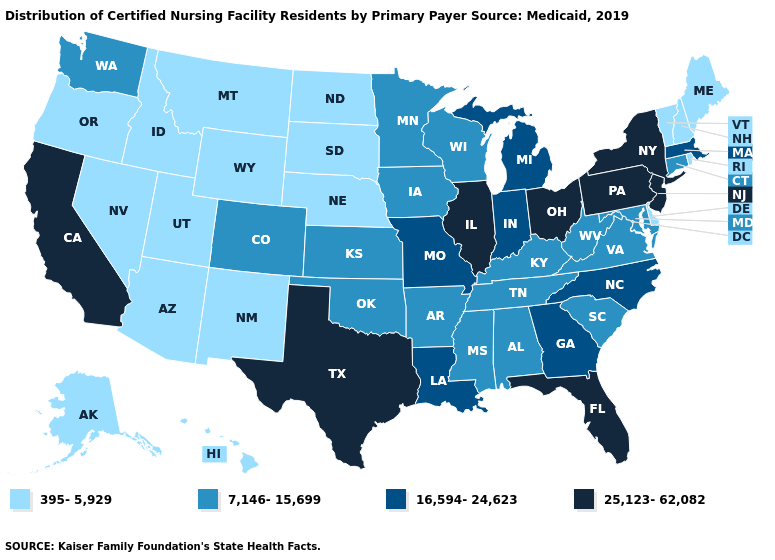What is the highest value in the Northeast ?
Quick response, please. 25,123-62,082. What is the highest value in the South ?
Short answer required. 25,123-62,082. Which states have the lowest value in the USA?
Write a very short answer. Alaska, Arizona, Delaware, Hawaii, Idaho, Maine, Montana, Nebraska, Nevada, New Hampshire, New Mexico, North Dakota, Oregon, Rhode Island, South Dakota, Utah, Vermont, Wyoming. Does Virginia have a higher value than Maryland?
Concise answer only. No. Name the states that have a value in the range 7,146-15,699?
Short answer required. Alabama, Arkansas, Colorado, Connecticut, Iowa, Kansas, Kentucky, Maryland, Minnesota, Mississippi, Oklahoma, South Carolina, Tennessee, Virginia, Washington, West Virginia, Wisconsin. Among the states that border Massachusetts , which have the highest value?
Keep it brief. New York. Name the states that have a value in the range 16,594-24,623?
Give a very brief answer. Georgia, Indiana, Louisiana, Massachusetts, Michigan, Missouri, North Carolina. Among the states that border Kentucky , which have the highest value?
Answer briefly. Illinois, Ohio. Does Wyoming have the same value as New Mexico?
Short answer required. Yes. What is the value of South Dakota?
Be succinct. 395-5,929. Name the states that have a value in the range 7,146-15,699?
Short answer required. Alabama, Arkansas, Colorado, Connecticut, Iowa, Kansas, Kentucky, Maryland, Minnesota, Mississippi, Oklahoma, South Carolina, Tennessee, Virginia, Washington, West Virginia, Wisconsin. What is the highest value in the USA?
Answer briefly. 25,123-62,082. What is the highest value in the MidWest ?
Keep it brief. 25,123-62,082. What is the lowest value in states that border South Dakota?
Concise answer only. 395-5,929. What is the value of Arizona?
Quick response, please. 395-5,929. 